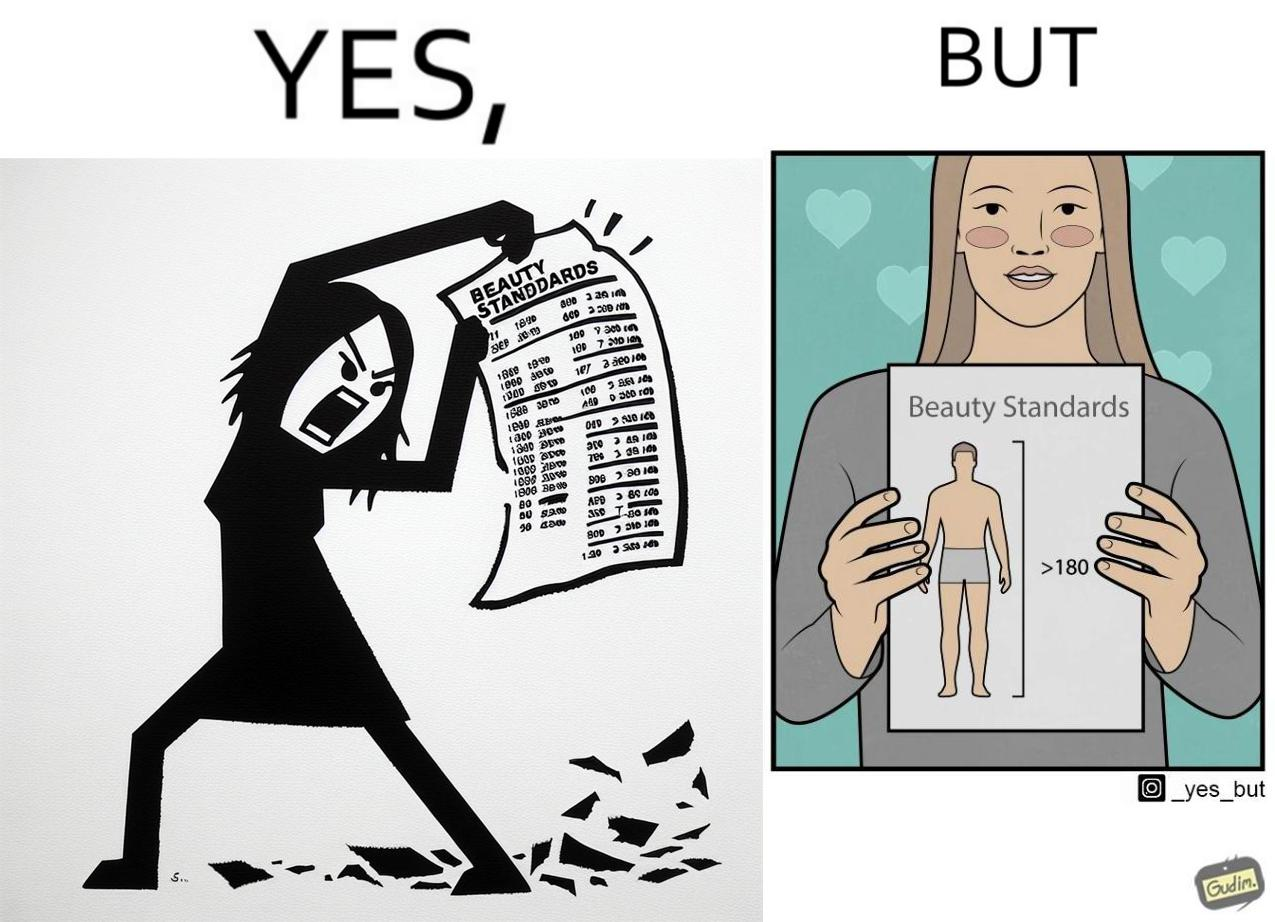What do you see in each half of this image? In the left part of the image: The image shows an angry woman tearing a piece of paper titled 'Beauty Standards' that shows the ideal measurements of various parts of a female's body to be called beautiful. In the right part of the image: The image shows a happy woman showing a piece of paper titled 'Beauty Standards' that shows that the ideal height of a male's body should be more than 180cm to be called beautiful. 